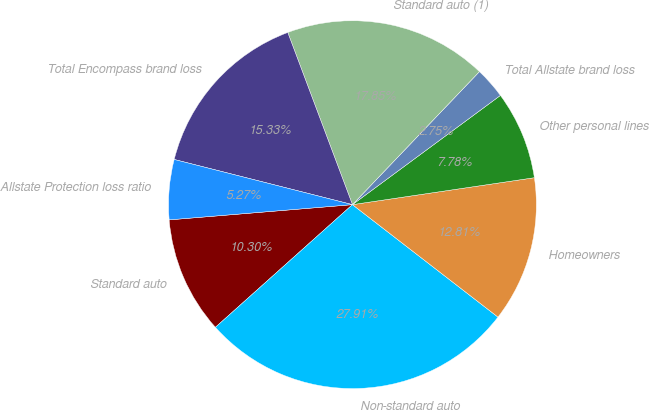<chart> <loc_0><loc_0><loc_500><loc_500><pie_chart><fcel>Standard auto<fcel>Non-standard auto<fcel>Homeowners<fcel>Other personal lines<fcel>Total Allstate brand loss<fcel>Standard auto (1)<fcel>Total Encompass brand loss<fcel>Allstate Protection loss ratio<nl><fcel>10.3%<fcel>27.91%<fcel>12.81%<fcel>7.78%<fcel>2.75%<fcel>17.85%<fcel>15.33%<fcel>5.27%<nl></chart> 